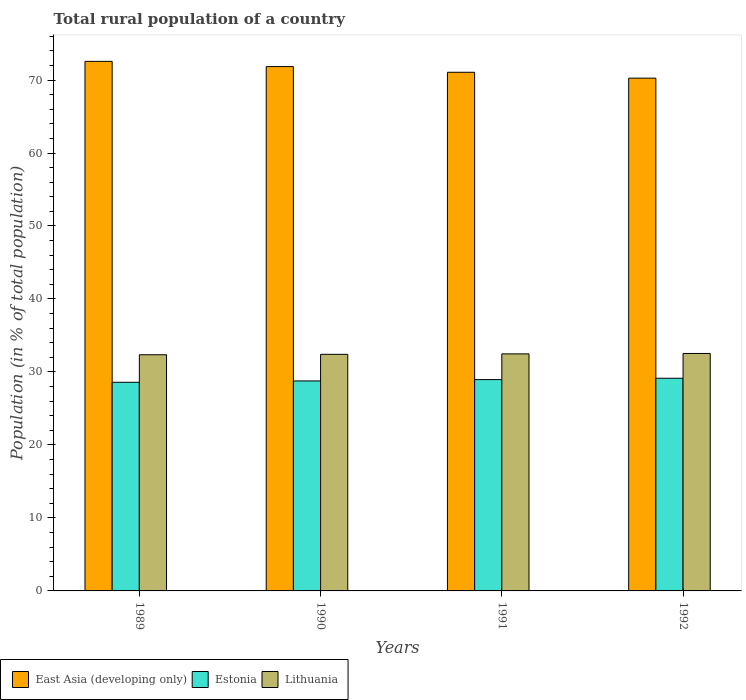How many different coloured bars are there?
Your answer should be very brief. 3. How many groups of bars are there?
Give a very brief answer. 4. Are the number of bars on each tick of the X-axis equal?
Offer a terse response. Yes. How many bars are there on the 1st tick from the right?
Your response must be concise. 3. What is the rural population in Lithuania in 1989?
Your response must be concise. 32.36. Across all years, what is the maximum rural population in Estonia?
Your answer should be very brief. 29.14. Across all years, what is the minimum rural population in Estonia?
Make the answer very short. 28.59. In which year was the rural population in East Asia (developing only) minimum?
Your answer should be compact. 1992. What is the total rural population in Estonia in the graph?
Give a very brief answer. 115.45. What is the difference between the rural population in Lithuania in 1989 and that in 1992?
Make the answer very short. -0.18. What is the difference between the rural population in Estonia in 1989 and the rural population in East Asia (developing only) in 1990?
Offer a terse response. -43.25. What is the average rural population in Estonia per year?
Keep it short and to the point. 28.86. In the year 1992, what is the difference between the rural population in Lithuania and rural population in East Asia (developing only)?
Make the answer very short. -37.72. In how many years, is the rural population in Lithuania greater than 60 %?
Keep it short and to the point. 0. What is the ratio of the rural population in Lithuania in 1989 to that in 1991?
Provide a succinct answer. 1. Is the rural population in East Asia (developing only) in 1991 less than that in 1992?
Your answer should be compact. No. Is the difference between the rural population in Lithuania in 1989 and 1991 greater than the difference between the rural population in East Asia (developing only) in 1989 and 1991?
Provide a short and direct response. No. What is the difference between the highest and the second highest rural population in East Asia (developing only)?
Give a very brief answer. 0.72. What is the difference between the highest and the lowest rural population in Lithuania?
Make the answer very short. 0.18. In how many years, is the rural population in East Asia (developing only) greater than the average rural population in East Asia (developing only) taken over all years?
Ensure brevity in your answer.  2. Is the sum of the rural population in Estonia in 1990 and 1991 greater than the maximum rural population in Lithuania across all years?
Your answer should be very brief. Yes. What does the 3rd bar from the left in 1991 represents?
Make the answer very short. Lithuania. What does the 3rd bar from the right in 1992 represents?
Offer a very short reply. East Asia (developing only). Does the graph contain any zero values?
Offer a terse response. No. Does the graph contain grids?
Make the answer very short. No. Where does the legend appear in the graph?
Provide a succinct answer. Bottom left. How many legend labels are there?
Offer a very short reply. 3. How are the legend labels stacked?
Your answer should be compact. Horizontal. What is the title of the graph?
Give a very brief answer. Total rural population of a country. Does "Brazil" appear as one of the legend labels in the graph?
Your answer should be very brief. No. What is the label or title of the Y-axis?
Make the answer very short. Population (in % of total population). What is the Population (in % of total population) of East Asia (developing only) in 1989?
Keep it short and to the point. 72.56. What is the Population (in % of total population) in Estonia in 1989?
Give a very brief answer. 28.59. What is the Population (in % of total population) of Lithuania in 1989?
Your answer should be compact. 32.36. What is the Population (in % of total population) of East Asia (developing only) in 1990?
Keep it short and to the point. 71.84. What is the Population (in % of total population) of Estonia in 1990?
Provide a succinct answer. 28.77. What is the Population (in % of total population) in Lithuania in 1990?
Offer a terse response. 32.42. What is the Population (in % of total population) in East Asia (developing only) in 1991?
Provide a short and direct response. 71.06. What is the Population (in % of total population) in Estonia in 1991?
Provide a succinct answer. 28.95. What is the Population (in % of total population) in Lithuania in 1991?
Provide a short and direct response. 32.48. What is the Population (in % of total population) in East Asia (developing only) in 1992?
Provide a short and direct response. 70.26. What is the Population (in % of total population) of Estonia in 1992?
Your answer should be very brief. 29.14. What is the Population (in % of total population) of Lithuania in 1992?
Give a very brief answer. 32.54. Across all years, what is the maximum Population (in % of total population) in East Asia (developing only)?
Your answer should be very brief. 72.56. Across all years, what is the maximum Population (in % of total population) of Estonia?
Ensure brevity in your answer.  29.14. Across all years, what is the maximum Population (in % of total population) in Lithuania?
Offer a very short reply. 32.54. Across all years, what is the minimum Population (in % of total population) of East Asia (developing only)?
Make the answer very short. 70.26. Across all years, what is the minimum Population (in % of total population) of Estonia?
Make the answer very short. 28.59. Across all years, what is the minimum Population (in % of total population) in Lithuania?
Give a very brief answer. 32.36. What is the total Population (in % of total population) in East Asia (developing only) in the graph?
Offer a very short reply. 285.71. What is the total Population (in % of total population) of Estonia in the graph?
Your response must be concise. 115.45. What is the total Population (in % of total population) in Lithuania in the graph?
Keep it short and to the point. 129.79. What is the difference between the Population (in % of total population) of East Asia (developing only) in 1989 and that in 1990?
Provide a succinct answer. 0.72. What is the difference between the Population (in % of total population) in Estonia in 1989 and that in 1990?
Make the answer very short. -0.18. What is the difference between the Population (in % of total population) in Lithuania in 1989 and that in 1990?
Provide a short and direct response. -0.06. What is the difference between the Population (in % of total population) in East Asia (developing only) in 1989 and that in 1991?
Your response must be concise. 1.5. What is the difference between the Population (in % of total population) in Estonia in 1989 and that in 1991?
Provide a short and direct response. -0.37. What is the difference between the Population (in % of total population) of Lithuania in 1989 and that in 1991?
Your response must be concise. -0.12. What is the difference between the Population (in % of total population) of East Asia (developing only) in 1989 and that in 1992?
Offer a terse response. 2.3. What is the difference between the Population (in % of total population) of Estonia in 1989 and that in 1992?
Your response must be concise. -0.56. What is the difference between the Population (in % of total population) in Lithuania in 1989 and that in 1992?
Your answer should be compact. -0.18. What is the difference between the Population (in % of total population) in East Asia (developing only) in 1990 and that in 1991?
Keep it short and to the point. 0.78. What is the difference between the Population (in % of total population) of Estonia in 1990 and that in 1991?
Your answer should be very brief. -0.18. What is the difference between the Population (in % of total population) of Lithuania in 1990 and that in 1991?
Provide a short and direct response. -0.06. What is the difference between the Population (in % of total population) of East Asia (developing only) in 1990 and that in 1992?
Your answer should be very brief. 1.58. What is the difference between the Population (in % of total population) in Estonia in 1990 and that in 1992?
Ensure brevity in your answer.  -0.37. What is the difference between the Population (in % of total population) of Lithuania in 1990 and that in 1992?
Your response must be concise. -0.12. What is the difference between the Population (in % of total population) of East Asia (developing only) in 1991 and that in 1992?
Make the answer very short. 0.8. What is the difference between the Population (in % of total population) in Estonia in 1991 and that in 1992?
Your answer should be compact. -0.19. What is the difference between the Population (in % of total population) in Lithuania in 1991 and that in 1992?
Ensure brevity in your answer.  -0.06. What is the difference between the Population (in % of total population) in East Asia (developing only) in 1989 and the Population (in % of total population) in Estonia in 1990?
Ensure brevity in your answer.  43.79. What is the difference between the Population (in % of total population) in East Asia (developing only) in 1989 and the Population (in % of total population) in Lithuania in 1990?
Give a very brief answer. 40.14. What is the difference between the Population (in % of total population) of Estonia in 1989 and the Population (in % of total population) of Lithuania in 1990?
Your answer should be compact. -3.83. What is the difference between the Population (in % of total population) in East Asia (developing only) in 1989 and the Population (in % of total population) in Estonia in 1991?
Your answer should be compact. 43.6. What is the difference between the Population (in % of total population) of East Asia (developing only) in 1989 and the Population (in % of total population) of Lithuania in 1991?
Your answer should be very brief. 40.08. What is the difference between the Population (in % of total population) of Estonia in 1989 and the Population (in % of total population) of Lithuania in 1991?
Your answer should be compact. -3.89. What is the difference between the Population (in % of total population) of East Asia (developing only) in 1989 and the Population (in % of total population) of Estonia in 1992?
Make the answer very short. 43.42. What is the difference between the Population (in % of total population) of East Asia (developing only) in 1989 and the Population (in % of total population) of Lithuania in 1992?
Your response must be concise. 40.02. What is the difference between the Population (in % of total population) of Estonia in 1989 and the Population (in % of total population) of Lithuania in 1992?
Your answer should be compact. -3.95. What is the difference between the Population (in % of total population) of East Asia (developing only) in 1990 and the Population (in % of total population) of Estonia in 1991?
Your answer should be very brief. 42.89. What is the difference between the Population (in % of total population) in East Asia (developing only) in 1990 and the Population (in % of total population) in Lithuania in 1991?
Offer a very short reply. 39.36. What is the difference between the Population (in % of total population) of Estonia in 1990 and the Population (in % of total population) of Lithuania in 1991?
Provide a succinct answer. -3.71. What is the difference between the Population (in % of total population) of East Asia (developing only) in 1990 and the Population (in % of total population) of Estonia in 1992?
Your response must be concise. 42.7. What is the difference between the Population (in % of total population) in East Asia (developing only) in 1990 and the Population (in % of total population) in Lithuania in 1992?
Keep it short and to the point. 39.3. What is the difference between the Population (in % of total population) of Estonia in 1990 and the Population (in % of total population) of Lithuania in 1992?
Offer a very short reply. -3.77. What is the difference between the Population (in % of total population) of East Asia (developing only) in 1991 and the Population (in % of total population) of Estonia in 1992?
Offer a very short reply. 41.92. What is the difference between the Population (in % of total population) in East Asia (developing only) in 1991 and the Population (in % of total population) in Lithuania in 1992?
Your answer should be very brief. 38.52. What is the difference between the Population (in % of total population) of Estonia in 1991 and the Population (in % of total population) of Lithuania in 1992?
Make the answer very short. -3.58. What is the average Population (in % of total population) of East Asia (developing only) per year?
Make the answer very short. 71.43. What is the average Population (in % of total population) of Estonia per year?
Make the answer very short. 28.86. What is the average Population (in % of total population) in Lithuania per year?
Provide a succinct answer. 32.45. In the year 1989, what is the difference between the Population (in % of total population) in East Asia (developing only) and Population (in % of total population) in Estonia?
Offer a very short reply. 43.97. In the year 1989, what is the difference between the Population (in % of total population) in East Asia (developing only) and Population (in % of total population) in Lithuania?
Offer a very short reply. 40.2. In the year 1989, what is the difference between the Population (in % of total population) in Estonia and Population (in % of total population) in Lithuania?
Offer a very short reply. -3.77. In the year 1990, what is the difference between the Population (in % of total population) of East Asia (developing only) and Population (in % of total population) of Estonia?
Offer a very short reply. 43.07. In the year 1990, what is the difference between the Population (in % of total population) of East Asia (developing only) and Population (in % of total population) of Lithuania?
Make the answer very short. 39.42. In the year 1990, what is the difference between the Population (in % of total population) of Estonia and Population (in % of total population) of Lithuania?
Offer a very short reply. -3.65. In the year 1991, what is the difference between the Population (in % of total population) in East Asia (developing only) and Population (in % of total population) in Estonia?
Your answer should be compact. 42.11. In the year 1991, what is the difference between the Population (in % of total population) of East Asia (developing only) and Population (in % of total population) of Lithuania?
Offer a terse response. 38.58. In the year 1991, what is the difference between the Population (in % of total population) of Estonia and Population (in % of total population) of Lithuania?
Ensure brevity in your answer.  -3.52. In the year 1992, what is the difference between the Population (in % of total population) of East Asia (developing only) and Population (in % of total population) of Estonia?
Ensure brevity in your answer.  41.12. In the year 1992, what is the difference between the Population (in % of total population) of East Asia (developing only) and Population (in % of total population) of Lithuania?
Offer a very short reply. 37.72. In the year 1992, what is the difference between the Population (in % of total population) of Estonia and Population (in % of total population) of Lithuania?
Give a very brief answer. -3.4. What is the ratio of the Population (in % of total population) in East Asia (developing only) in 1989 to that in 1990?
Ensure brevity in your answer.  1.01. What is the ratio of the Population (in % of total population) in East Asia (developing only) in 1989 to that in 1991?
Offer a very short reply. 1.02. What is the ratio of the Population (in % of total population) in Estonia in 1989 to that in 1991?
Provide a succinct answer. 0.99. What is the ratio of the Population (in % of total population) in Lithuania in 1989 to that in 1991?
Give a very brief answer. 1. What is the ratio of the Population (in % of total population) in East Asia (developing only) in 1989 to that in 1992?
Provide a short and direct response. 1.03. What is the ratio of the Population (in % of total population) in Estonia in 1989 to that in 1992?
Your response must be concise. 0.98. What is the ratio of the Population (in % of total population) in Lithuania in 1989 to that in 1992?
Your response must be concise. 0.99. What is the ratio of the Population (in % of total population) in Estonia in 1990 to that in 1991?
Give a very brief answer. 0.99. What is the ratio of the Population (in % of total population) of Lithuania in 1990 to that in 1991?
Give a very brief answer. 1. What is the ratio of the Population (in % of total population) of East Asia (developing only) in 1990 to that in 1992?
Offer a terse response. 1.02. What is the ratio of the Population (in % of total population) in Estonia in 1990 to that in 1992?
Give a very brief answer. 0.99. What is the ratio of the Population (in % of total population) of Lithuania in 1990 to that in 1992?
Ensure brevity in your answer.  1. What is the ratio of the Population (in % of total population) of East Asia (developing only) in 1991 to that in 1992?
Ensure brevity in your answer.  1.01. What is the difference between the highest and the second highest Population (in % of total population) in East Asia (developing only)?
Your response must be concise. 0.72. What is the difference between the highest and the second highest Population (in % of total population) in Estonia?
Your answer should be compact. 0.19. What is the difference between the highest and the second highest Population (in % of total population) of Lithuania?
Provide a succinct answer. 0.06. What is the difference between the highest and the lowest Population (in % of total population) in East Asia (developing only)?
Provide a short and direct response. 2.3. What is the difference between the highest and the lowest Population (in % of total population) in Estonia?
Offer a very short reply. 0.56. What is the difference between the highest and the lowest Population (in % of total population) in Lithuania?
Keep it short and to the point. 0.18. 